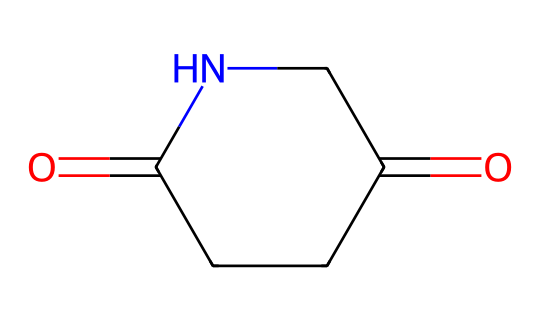What is the name of this chemical? The SMILES representation corresponds to glutarimide, which is derived from glutaric acid and features an imide functional group.
Answer: glutarimide How many carbon atoms are in glutarimide? Counting the carbon atoms in the SMILES representation, there are five carbon atoms in total, which are part of the cyclized structure.
Answer: five What type of functional group is present in glutarimide? The structure shows a carbonyl group (C=O) adjacent to a nitrogen, indicating the presence of an imide functional group characterized by two carbonyl groups attached to a nitrogen atom.
Answer: imide What is the total number of hydrogen atoms in glutarimide? To find the total number of hydrogen atoms, we can analyze the structure: there are eight hydrogen atoms across the entire molecule, which can be deduced from the connectivity in the SMILES.
Answer: eight How many rings does glutarimide have in its structure? In the provided SMILES notation, there is one ring structure present, which is a cyclic imide, formed by connecting the carbon atoms and the nitrogen in the cycle.
Answer: one What is the degree of unsaturation in glutarimide? The degree of unsaturation can be determined by analyzing the number of rings and double bonds; glutarimide has a saturation calculation of two, considering one ring and one double bond.
Answer: two Does glutarimide exhibit characteristics typical of imides? Yes, glutarimide exhibits characteristics typical of imides, such as the presence of a nitrogen atom bonded to two carbonyl groups, which is a hallmark of imide functionality.
Answer: yes 